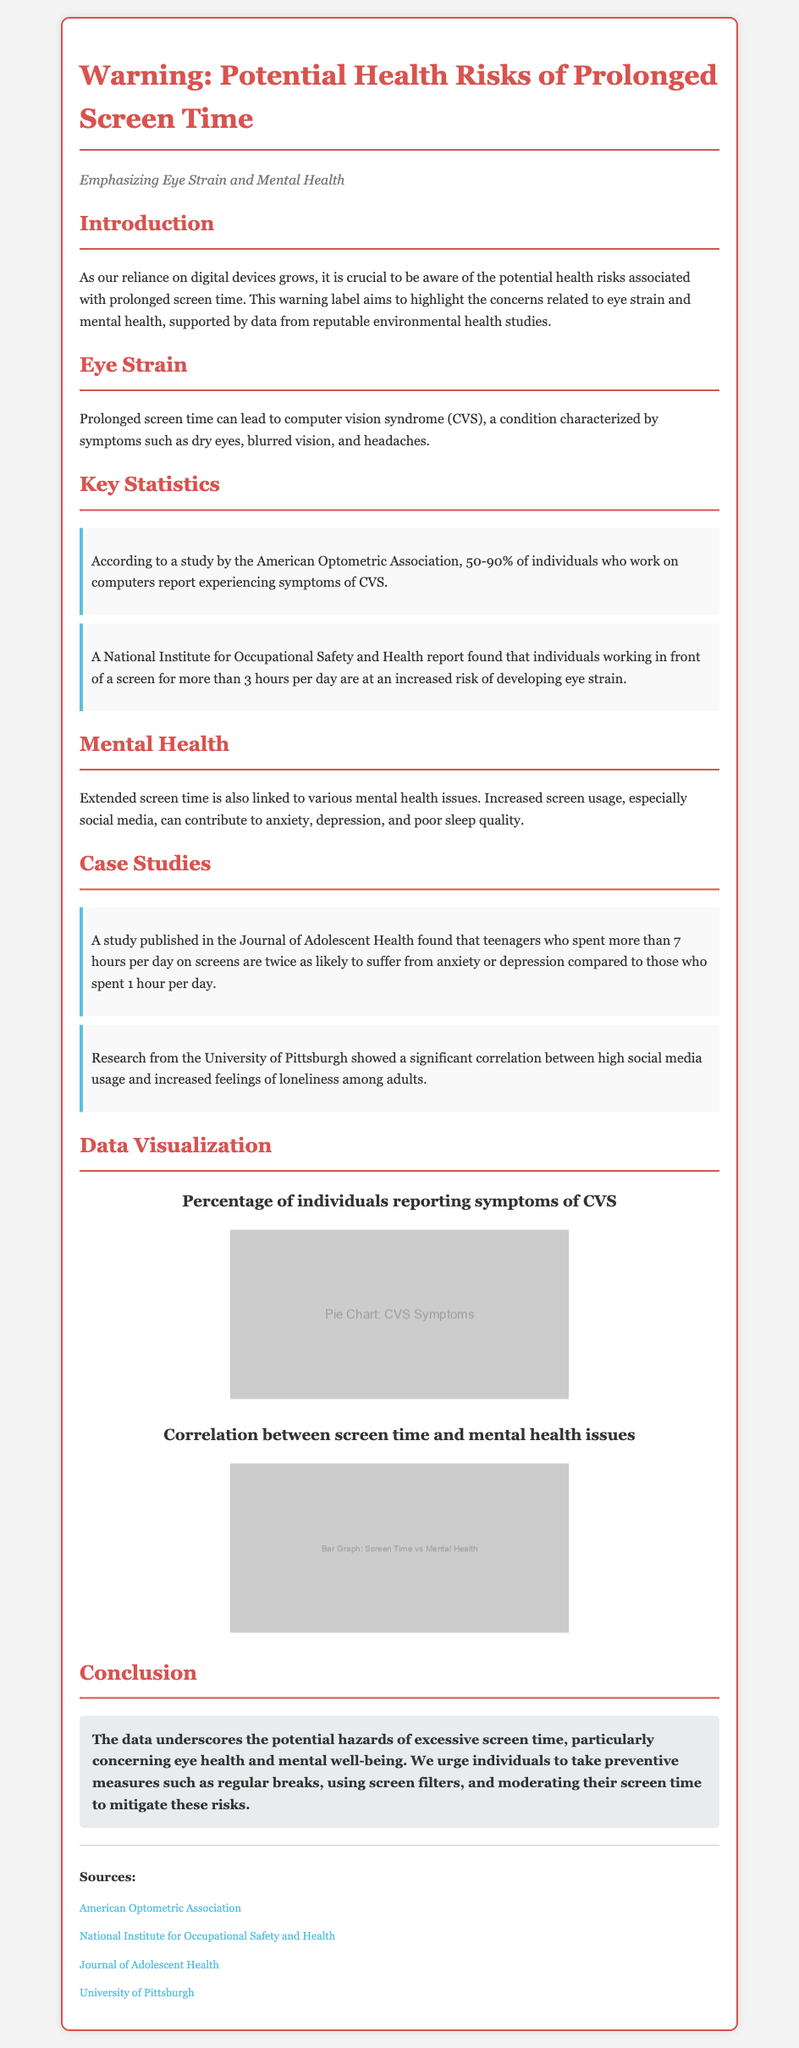What is the percentage of individuals reporting symptoms of CVS? The document mentions that 50-90% of individuals who work on computers report experiencing symptoms of CVS.
Answer: 50-90% How many hours of screen usage per day increases eye strain risk? A report found that individuals working in front of a screen for more than 3 hours per day are at an increased risk of developing eye strain.
Answer: More than 3 hours What effect does screen time have on teenagers' mental health? The study found that teenagers who spent more than 7 hours per day on screens are twice as likely to suffer from anxiety or depression compared to those who spent 1 hour per day.
Answer: Twice as likely Which organization conducted a study on computer vision syndrome? The American Optometric Association conducted a study reporting the percentage of individuals experiencing CVS symptoms.
Answer: American Optometric Association What is a recommended preventive measure to mitigate screen time risks? The conclusion suggests taking regular breaks as a preventive measure against the risks of prolonged screen time.
Answer: Regular breaks 